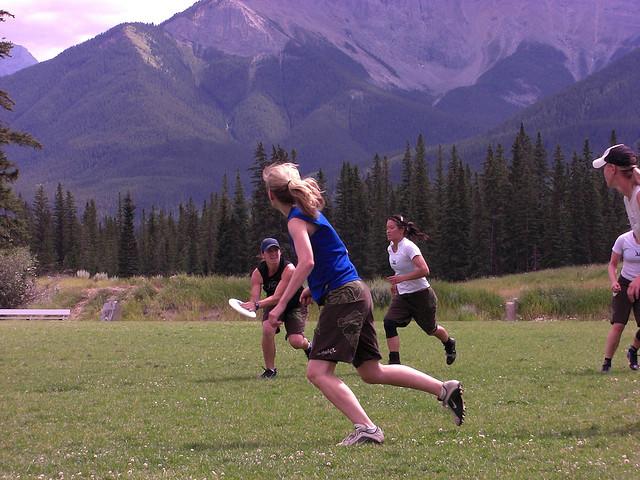What game are the people playing?
Write a very short answer. Frisbee. Are the girls pretty?
Concise answer only. Yes. What landform is in the background?
Write a very short answer. Mountain. 